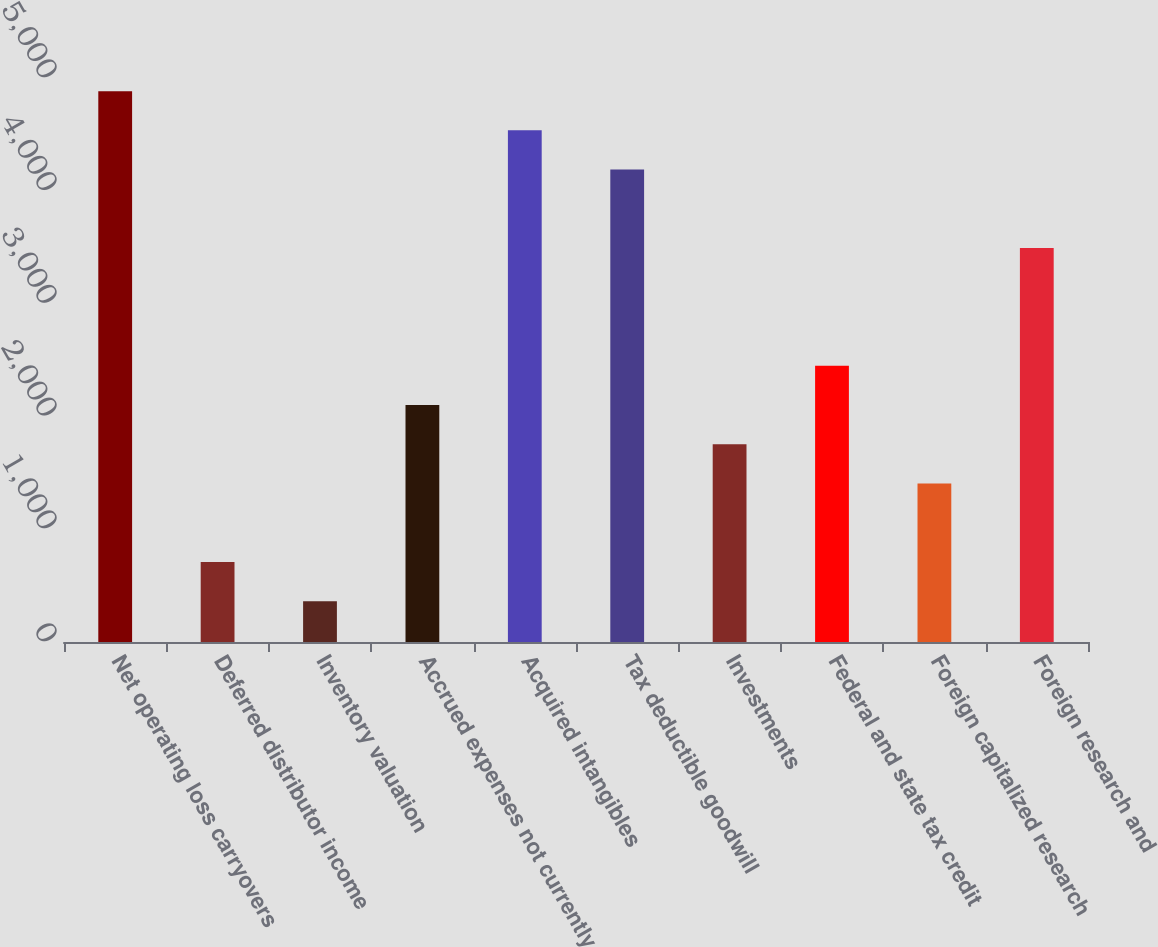Convert chart. <chart><loc_0><loc_0><loc_500><loc_500><bar_chart><fcel>Net operating loss carryovers<fcel>Deferred distributor income<fcel>Inventory valuation<fcel>Accrued expenses not currently<fcel>Acquired intangibles<fcel>Tax deductible goodwill<fcel>Investments<fcel>Federal and state tax credit<fcel>Foreign capitalized research<fcel>Foreign research and<nl><fcel>4883.6<fcel>708.8<fcel>360.9<fcel>2100.4<fcel>4535.7<fcel>4187.8<fcel>1752.5<fcel>2448.3<fcel>1404.6<fcel>3492<nl></chart> 